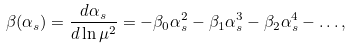<formula> <loc_0><loc_0><loc_500><loc_500>\beta ( \alpha _ { s } ) = \frac { d \alpha _ { s } } { d \ln \mu ^ { 2 } } = - \beta _ { 0 } \alpha _ { s } ^ { 2 } - \beta _ { 1 } \alpha _ { s } ^ { 3 } - \beta _ { 2 } \alpha _ { s } ^ { 4 } - \dots ,</formula> 